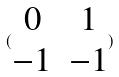<formula> <loc_0><loc_0><loc_500><loc_500>( \begin{matrix} 0 & 1 \\ - 1 & - 1 \end{matrix} )</formula> 